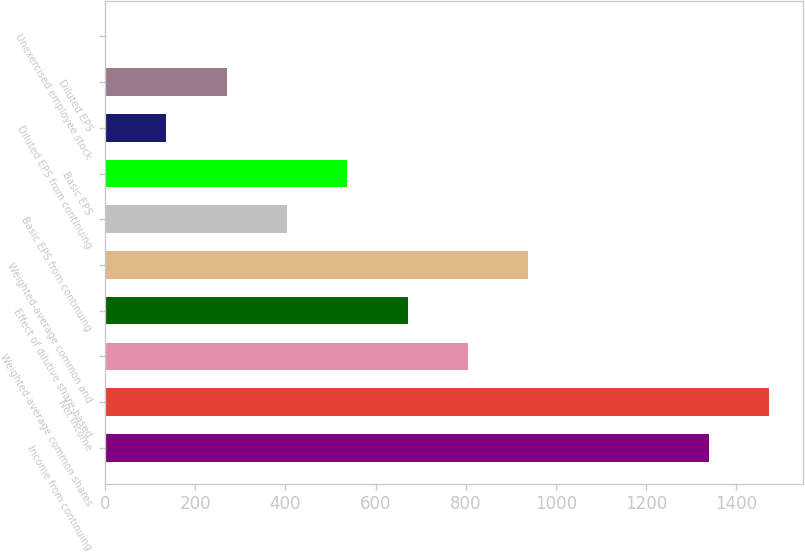<chart> <loc_0><loc_0><loc_500><loc_500><bar_chart><fcel>Income from continuing<fcel>Net Income<fcel>Weighted-average common shares<fcel>Effect of dilutive share-based<fcel>Weighted-average common and<fcel>Basic EPS from continuing<fcel>Basic EPS<fcel>Diluted EPS from continuing<fcel>Diluted EPS<fcel>Unexercised employee stock<nl><fcel>1340<fcel>1473.77<fcel>804.92<fcel>671.15<fcel>938.69<fcel>403.61<fcel>537.38<fcel>136.07<fcel>269.84<fcel>2.3<nl></chart> 